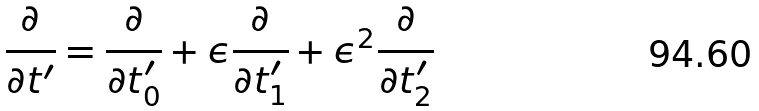<formula> <loc_0><loc_0><loc_500><loc_500>\frac { \partial } { \partial t ^ { \prime } } = \frac { \partial } { \partial t _ { 0 } ^ { \prime } } + \epsilon \frac { \partial } { \partial t _ { 1 } ^ { \prime } } + \epsilon ^ { 2 } \frac { \partial } { \partial t _ { 2 } ^ { \prime } }</formula> 